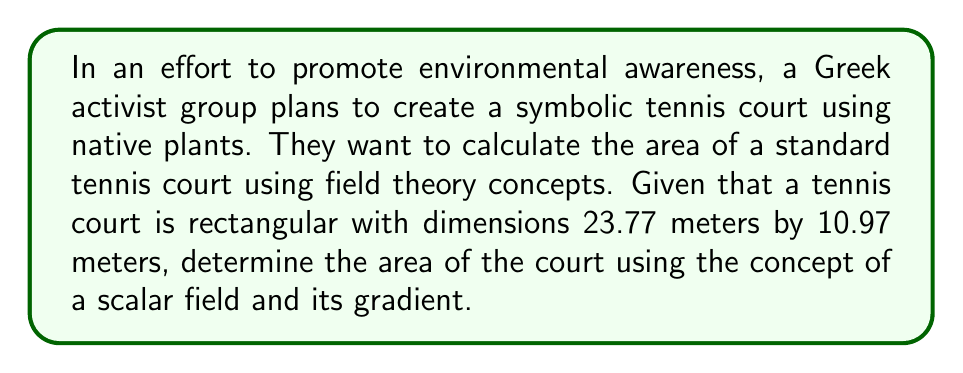Solve this math problem. Let's approach this step-by-step using field theory concepts:

1) Define a scalar field $f(x,y)$ over the tennis court:
   $$f(x,y) = 1$$
   This constant field represents a uniform "density" over the court.

2) The gradient of this field is:
   $$\nabla f = \left(\frac{\partial f}{\partial x}, \frac{\partial f}{\partial y}\right) = (0, 0)$$

3) To find the area, we need to integrate the scalar field over the region:
   $$A = \iint_R f(x,y) \, dA$$

4) Using the divergence theorem, we can convert this to a line integral:
   $$A = \iint_R f(x,y) \, dA = \oint_C \mathbf{F} \cdot \mathbf{n} \, ds$$
   where $\mathbf{F}$ is a vector field whose divergence is $f(x,y)$, and $\mathbf{n}$ is the outward unit normal vector.

5) We can choose $\mathbf{F} = (\frac{x}{2}, \frac{y}{2})$ since $\nabla \cdot \mathbf{F} = 1 = f(x,y)$

6) Parameterize the boundary of the tennis court:
   - Bottom: $(t, 0)$, $0 \leq t \leq 23.77$
   - Right: $(23.77, t)$, $0 \leq t \leq 10.97$
   - Top: $(23.77 - t, 10.97)$, $0 \leq t \leq 23.77$
   - Left: $(0, 10.97 - t)$, $0 \leq t \leq 10.97$

7) Evaluate the line integral:
   $$A = \int_0^{23.77} \frac{t}{2} \, dt + \int_0^{10.97} \frac{23.77}{2} \, dt + \int_0^{23.77} \frac{23.77 - t}{2} \, dt + \int_0^{10.97} \frac{10.97 - t}{2} \, dt$$

8) Solving this integral:
   $$A = \left[\frac{t^2}{4}\right]_0^{23.77} + \left[\frac{23.77t}{2}\right]_0^{10.97} + \left[\frac{23.77t}{2} - \frac{t^2}{4}\right]_0^{23.77} + \left[\frac{10.97t}{2} - \frac{t^2}{4}\right]_0^{10.97}$$

9) Calculating the result:
   $$A = 141.3025 + 130.3784 + 141.3025 + 60.0756 = 473.059 \text{ m}^2$$
Answer: 473.059 m² 